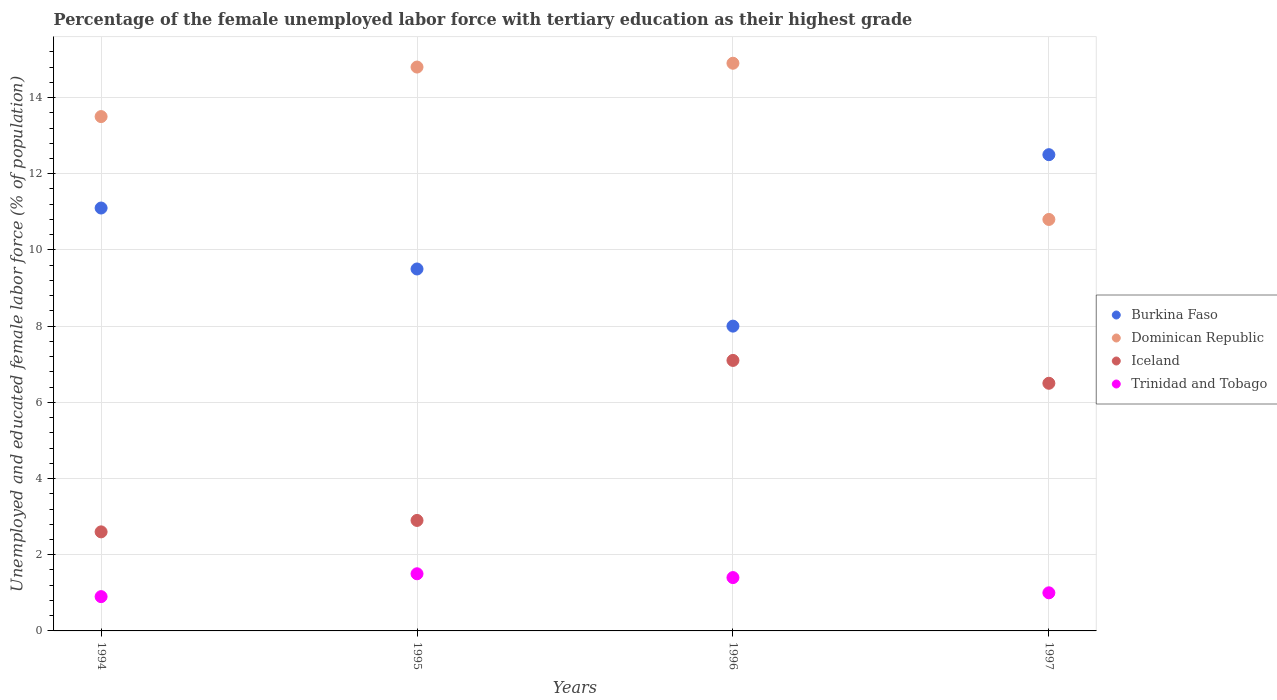How many different coloured dotlines are there?
Give a very brief answer. 4. Across all years, what is the maximum percentage of the unemployed female labor force with tertiary education in Dominican Republic?
Give a very brief answer. 14.9. Across all years, what is the minimum percentage of the unemployed female labor force with tertiary education in Trinidad and Tobago?
Keep it short and to the point. 0.9. In which year was the percentage of the unemployed female labor force with tertiary education in Dominican Republic maximum?
Offer a terse response. 1996. What is the total percentage of the unemployed female labor force with tertiary education in Dominican Republic in the graph?
Offer a very short reply. 54. What is the difference between the percentage of the unemployed female labor force with tertiary education in Iceland in 1995 and that in 1996?
Offer a very short reply. -4.2. What is the difference between the percentage of the unemployed female labor force with tertiary education in Trinidad and Tobago in 1994 and the percentage of the unemployed female labor force with tertiary education in Burkina Faso in 1995?
Provide a succinct answer. -8.6. What is the average percentage of the unemployed female labor force with tertiary education in Iceland per year?
Your response must be concise. 4.77. In the year 1994, what is the difference between the percentage of the unemployed female labor force with tertiary education in Iceland and percentage of the unemployed female labor force with tertiary education in Trinidad and Tobago?
Make the answer very short. 1.7. What is the ratio of the percentage of the unemployed female labor force with tertiary education in Dominican Republic in 1994 to that in 1997?
Give a very brief answer. 1.25. Is the percentage of the unemployed female labor force with tertiary education in Iceland in 1994 less than that in 1996?
Keep it short and to the point. Yes. What is the difference between the highest and the second highest percentage of the unemployed female labor force with tertiary education in Trinidad and Tobago?
Your answer should be compact. 0.1. What is the difference between the highest and the lowest percentage of the unemployed female labor force with tertiary education in Trinidad and Tobago?
Ensure brevity in your answer.  0.6. Is the sum of the percentage of the unemployed female labor force with tertiary education in Iceland in 1996 and 1997 greater than the maximum percentage of the unemployed female labor force with tertiary education in Trinidad and Tobago across all years?
Provide a succinct answer. Yes. Is it the case that in every year, the sum of the percentage of the unemployed female labor force with tertiary education in Trinidad and Tobago and percentage of the unemployed female labor force with tertiary education in Burkina Faso  is greater than the sum of percentage of the unemployed female labor force with tertiary education in Dominican Republic and percentage of the unemployed female labor force with tertiary education in Iceland?
Offer a very short reply. Yes. Is it the case that in every year, the sum of the percentage of the unemployed female labor force with tertiary education in Burkina Faso and percentage of the unemployed female labor force with tertiary education in Dominican Republic  is greater than the percentage of the unemployed female labor force with tertiary education in Trinidad and Tobago?
Your answer should be compact. Yes. Does the percentage of the unemployed female labor force with tertiary education in Dominican Republic monotonically increase over the years?
Your response must be concise. No. Is the percentage of the unemployed female labor force with tertiary education in Dominican Republic strictly greater than the percentage of the unemployed female labor force with tertiary education in Trinidad and Tobago over the years?
Make the answer very short. Yes. How many years are there in the graph?
Your answer should be very brief. 4. Does the graph contain any zero values?
Provide a short and direct response. No. Where does the legend appear in the graph?
Offer a very short reply. Center right. How many legend labels are there?
Offer a very short reply. 4. How are the legend labels stacked?
Provide a short and direct response. Vertical. What is the title of the graph?
Keep it short and to the point. Percentage of the female unemployed labor force with tertiary education as their highest grade. What is the label or title of the Y-axis?
Keep it short and to the point. Unemployed and educated female labor force (% of population). What is the Unemployed and educated female labor force (% of population) of Burkina Faso in 1994?
Your answer should be very brief. 11.1. What is the Unemployed and educated female labor force (% of population) of Dominican Republic in 1994?
Ensure brevity in your answer.  13.5. What is the Unemployed and educated female labor force (% of population) of Iceland in 1994?
Ensure brevity in your answer.  2.6. What is the Unemployed and educated female labor force (% of population) in Trinidad and Tobago in 1994?
Provide a succinct answer. 0.9. What is the Unemployed and educated female labor force (% of population) in Dominican Republic in 1995?
Give a very brief answer. 14.8. What is the Unemployed and educated female labor force (% of population) of Iceland in 1995?
Your answer should be compact. 2.9. What is the Unemployed and educated female labor force (% of population) in Burkina Faso in 1996?
Make the answer very short. 8. What is the Unemployed and educated female labor force (% of population) of Dominican Republic in 1996?
Keep it short and to the point. 14.9. What is the Unemployed and educated female labor force (% of population) in Iceland in 1996?
Your answer should be compact. 7.1. What is the Unemployed and educated female labor force (% of population) of Trinidad and Tobago in 1996?
Provide a succinct answer. 1.4. What is the Unemployed and educated female labor force (% of population) in Burkina Faso in 1997?
Ensure brevity in your answer.  12.5. What is the Unemployed and educated female labor force (% of population) of Dominican Republic in 1997?
Provide a short and direct response. 10.8. What is the Unemployed and educated female labor force (% of population) of Iceland in 1997?
Your response must be concise. 6.5. Across all years, what is the maximum Unemployed and educated female labor force (% of population) in Burkina Faso?
Offer a very short reply. 12.5. Across all years, what is the maximum Unemployed and educated female labor force (% of population) of Dominican Republic?
Offer a very short reply. 14.9. Across all years, what is the maximum Unemployed and educated female labor force (% of population) of Iceland?
Keep it short and to the point. 7.1. Across all years, what is the minimum Unemployed and educated female labor force (% of population) in Burkina Faso?
Provide a short and direct response. 8. Across all years, what is the minimum Unemployed and educated female labor force (% of population) in Dominican Republic?
Make the answer very short. 10.8. Across all years, what is the minimum Unemployed and educated female labor force (% of population) in Iceland?
Offer a very short reply. 2.6. Across all years, what is the minimum Unemployed and educated female labor force (% of population) of Trinidad and Tobago?
Give a very brief answer. 0.9. What is the total Unemployed and educated female labor force (% of population) in Burkina Faso in the graph?
Your answer should be compact. 41.1. What is the total Unemployed and educated female labor force (% of population) in Dominican Republic in the graph?
Your answer should be very brief. 54. What is the total Unemployed and educated female labor force (% of population) of Trinidad and Tobago in the graph?
Your answer should be compact. 4.8. What is the difference between the Unemployed and educated female labor force (% of population) in Iceland in 1994 and that in 1996?
Your answer should be compact. -4.5. What is the difference between the Unemployed and educated female labor force (% of population) of Trinidad and Tobago in 1994 and that in 1996?
Your response must be concise. -0.5. What is the difference between the Unemployed and educated female labor force (% of population) of Iceland in 1994 and that in 1997?
Keep it short and to the point. -3.9. What is the difference between the Unemployed and educated female labor force (% of population) of Burkina Faso in 1995 and that in 1996?
Your response must be concise. 1.5. What is the difference between the Unemployed and educated female labor force (% of population) of Iceland in 1995 and that in 1996?
Offer a terse response. -4.2. What is the difference between the Unemployed and educated female labor force (% of population) in Trinidad and Tobago in 1995 and that in 1996?
Your response must be concise. 0.1. What is the difference between the Unemployed and educated female labor force (% of population) in Burkina Faso in 1995 and that in 1997?
Ensure brevity in your answer.  -3. What is the difference between the Unemployed and educated female labor force (% of population) in Iceland in 1995 and that in 1997?
Keep it short and to the point. -3.6. What is the difference between the Unemployed and educated female labor force (% of population) of Trinidad and Tobago in 1995 and that in 1997?
Your answer should be compact. 0.5. What is the difference between the Unemployed and educated female labor force (% of population) of Burkina Faso in 1996 and that in 1997?
Your answer should be compact. -4.5. What is the difference between the Unemployed and educated female labor force (% of population) in Dominican Republic in 1996 and that in 1997?
Your answer should be compact. 4.1. What is the difference between the Unemployed and educated female labor force (% of population) in Iceland in 1996 and that in 1997?
Offer a very short reply. 0.6. What is the difference between the Unemployed and educated female labor force (% of population) of Burkina Faso in 1994 and the Unemployed and educated female labor force (% of population) of Dominican Republic in 1995?
Offer a very short reply. -3.7. What is the difference between the Unemployed and educated female labor force (% of population) in Burkina Faso in 1994 and the Unemployed and educated female labor force (% of population) in Iceland in 1995?
Make the answer very short. 8.2. What is the difference between the Unemployed and educated female labor force (% of population) in Dominican Republic in 1994 and the Unemployed and educated female labor force (% of population) in Iceland in 1995?
Your answer should be very brief. 10.6. What is the difference between the Unemployed and educated female labor force (% of population) in Burkina Faso in 1994 and the Unemployed and educated female labor force (% of population) in Dominican Republic in 1996?
Your answer should be compact. -3.8. What is the difference between the Unemployed and educated female labor force (% of population) in Burkina Faso in 1994 and the Unemployed and educated female labor force (% of population) in Trinidad and Tobago in 1996?
Provide a short and direct response. 9.7. What is the difference between the Unemployed and educated female labor force (% of population) in Dominican Republic in 1994 and the Unemployed and educated female labor force (% of population) in Iceland in 1996?
Keep it short and to the point. 6.4. What is the difference between the Unemployed and educated female labor force (% of population) in Dominican Republic in 1994 and the Unemployed and educated female labor force (% of population) in Trinidad and Tobago in 1996?
Give a very brief answer. 12.1. What is the difference between the Unemployed and educated female labor force (% of population) in Burkina Faso in 1994 and the Unemployed and educated female labor force (% of population) in Trinidad and Tobago in 1997?
Offer a very short reply. 10.1. What is the difference between the Unemployed and educated female labor force (% of population) of Burkina Faso in 1995 and the Unemployed and educated female labor force (% of population) of Dominican Republic in 1996?
Your answer should be compact. -5.4. What is the difference between the Unemployed and educated female labor force (% of population) of Burkina Faso in 1995 and the Unemployed and educated female labor force (% of population) of Iceland in 1996?
Make the answer very short. 2.4. What is the difference between the Unemployed and educated female labor force (% of population) of Burkina Faso in 1995 and the Unemployed and educated female labor force (% of population) of Trinidad and Tobago in 1996?
Offer a terse response. 8.1. What is the difference between the Unemployed and educated female labor force (% of population) in Burkina Faso in 1995 and the Unemployed and educated female labor force (% of population) in Iceland in 1997?
Ensure brevity in your answer.  3. What is the difference between the Unemployed and educated female labor force (% of population) in Iceland in 1995 and the Unemployed and educated female labor force (% of population) in Trinidad and Tobago in 1997?
Ensure brevity in your answer.  1.9. What is the difference between the Unemployed and educated female labor force (% of population) in Burkina Faso in 1996 and the Unemployed and educated female labor force (% of population) in Dominican Republic in 1997?
Your response must be concise. -2.8. What is the difference between the Unemployed and educated female labor force (% of population) in Burkina Faso in 1996 and the Unemployed and educated female labor force (% of population) in Iceland in 1997?
Your answer should be compact. 1.5. What is the difference between the Unemployed and educated female labor force (% of population) of Burkina Faso in 1996 and the Unemployed and educated female labor force (% of population) of Trinidad and Tobago in 1997?
Make the answer very short. 7. What is the difference between the Unemployed and educated female labor force (% of population) in Iceland in 1996 and the Unemployed and educated female labor force (% of population) in Trinidad and Tobago in 1997?
Your response must be concise. 6.1. What is the average Unemployed and educated female labor force (% of population) of Burkina Faso per year?
Provide a short and direct response. 10.28. What is the average Unemployed and educated female labor force (% of population) of Dominican Republic per year?
Your response must be concise. 13.5. What is the average Unemployed and educated female labor force (% of population) of Iceland per year?
Your answer should be compact. 4.78. In the year 1994, what is the difference between the Unemployed and educated female labor force (% of population) of Burkina Faso and Unemployed and educated female labor force (% of population) of Iceland?
Offer a terse response. 8.5. In the year 1994, what is the difference between the Unemployed and educated female labor force (% of population) of Burkina Faso and Unemployed and educated female labor force (% of population) of Trinidad and Tobago?
Provide a short and direct response. 10.2. In the year 1994, what is the difference between the Unemployed and educated female labor force (% of population) of Iceland and Unemployed and educated female labor force (% of population) of Trinidad and Tobago?
Give a very brief answer. 1.7. In the year 1995, what is the difference between the Unemployed and educated female labor force (% of population) of Burkina Faso and Unemployed and educated female labor force (% of population) of Dominican Republic?
Ensure brevity in your answer.  -5.3. In the year 1995, what is the difference between the Unemployed and educated female labor force (% of population) in Burkina Faso and Unemployed and educated female labor force (% of population) in Iceland?
Offer a terse response. 6.6. In the year 1995, what is the difference between the Unemployed and educated female labor force (% of population) of Dominican Republic and Unemployed and educated female labor force (% of population) of Iceland?
Your answer should be compact. 11.9. In the year 1995, what is the difference between the Unemployed and educated female labor force (% of population) in Dominican Republic and Unemployed and educated female labor force (% of population) in Trinidad and Tobago?
Offer a very short reply. 13.3. In the year 1996, what is the difference between the Unemployed and educated female labor force (% of population) of Dominican Republic and Unemployed and educated female labor force (% of population) of Trinidad and Tobago?
Give a very brief answer. 13.5. In the year 1997, what is the difference between the Unemployed and educated female labor force (% of population) in Burkina Faso and Unemployed and educated female labor force (% of population) in Trinidad and Tobago?
Provide a short and direct response. 11.5. In the year 1997, what is the difference between the Unemployed and educated female labor force (% of population) in Dominican Republic and Unemployed and educated female labor force (% of population) in Trinidad and Tobago?
Offer a very short reply. 9.8. What is the ratio of the Unemployed and educated female labor force (% of population) in Burkina Faso in 1994 to that in 1995?
Your response must be concise. 1.17. What is the ratio of the Unemployed and educated female labor force (% of population) in Dominican Republic in 1994 to that in 1995?
Provide a succinct answer. 0.91. What is the ratio of the Unemployed and educated female labor force (% of population) in Iceland in 1994 to that in 1995?
Give a very brief answer. 0.9. What is the ratio of the Unemployed and educated female labor force (% of population) of Trinidad and Tobago in 1994 to that in 1995?
Give a very brief answer. 0.6. What is the ratio of the Unemployed and educated female labor force (% of population) of Burkina Faso in 1994 to that in 1996?
Give a very brief answer. 1.39. What is the ratio of the Unemployed and educated female labor force (% of population) of Dominican Republic in 1994 to that in 1996?
Keep it short and to the point. 0.91. What is the ratio of the Unemployed and educated female labor force (% of population) of Iceland in 1994 to that in 1996?
Your answer should be compact. 0.37. What is the ratio of the Unemployed and educated female labor force (% of population) in Trinidad and Tobago in 1994 to that in 1996?
Keep it short and to the point. 0.64. What is the ratio of the Unemployed and educated female labor force (% of population) of Burkina Faso in 1994 to that in 1997?
Provide a succinct answer. 0.89. What is the ratio of the Unemployed and educated female labor force (% of population) of Iceland in 1994 to that in 1997?
Offer a terse response. 0.4. What is the ratio of the Unemployed and educated female labor force (% of population) in Burkina Faso in 1995 to that in 1996?
Offer a terse response. 1.19. What is the ratio of the Unemployed and educated female labor force (% of population) of Dominican Republic in 1995 to that in 1996?
Make the answer very short. 0.99. What is the ratio of the Unemployed and educated female labor force (% of population) of Iceland in 1995 to that in 1996?
Ensure brevity in your answer.  0.41. What is the ratio of the Unemployed and educated female labor force (% of population) in Trinidad and Tobago in 1995 to that in 1996?
Keep it short and to the point. 1.07. What is the ratio of the Unemployed and educated female labor force (% of population) in Burkina Faso in 1995 to that in 1997?
Provide a succinct answer. 0.76. What is the ratio of the Unemployed and educated female labor force (% of population) in Dominican Republic in 1995 to that in 1997?
Provide a succinct answer. 1.37. What is the ratio of the Unemployed and educated female labor force (% of population) of Iceland in 1995 to that in 1997?
Provide a short and direct response. 0.45. What is the ratio of the Unemployed and educated female labor force (% of population) of Burkina Faso in 1996 to that in 1997?
Keep it short and to the point. 0.64. What is the ratio of the Unemployed and educated female labor force (% of population) of Dominican Republic in 1996 to that in 1997?
Provide a short and direct response. 1.38. What is the ratio of the Unemployed and educated female labor force (% of population) of Iceland in 1996 to that in 1997?
Your answer should be very brief. 1.09. What is the ratio of the Unemployed and educated female labor force (% of population) in Trinidad and Tobago in 1996 to that in 1997?
Provide a succinct answer. 1.4. What is the difference between the highest and the second highest Unemployed and educated female labor force (% of population) in Burkina Faso?
Your response must be concise. 1.4. What is the difference between the highest and the second highest Unemployed and educated female labor force (% of population) in Iceland?
Offer a terse response. 0.6. What is the difference between the highest and the second highest Unemployed and educated female labor force (% of population) of Trinidad and Tobago?
Offer a very short reply. 0.1. What is the difference between the highest and the lowest Unemployed and educated female labor force (% of population) of Burkina Faso?
Make the answer very short. 4.5. 